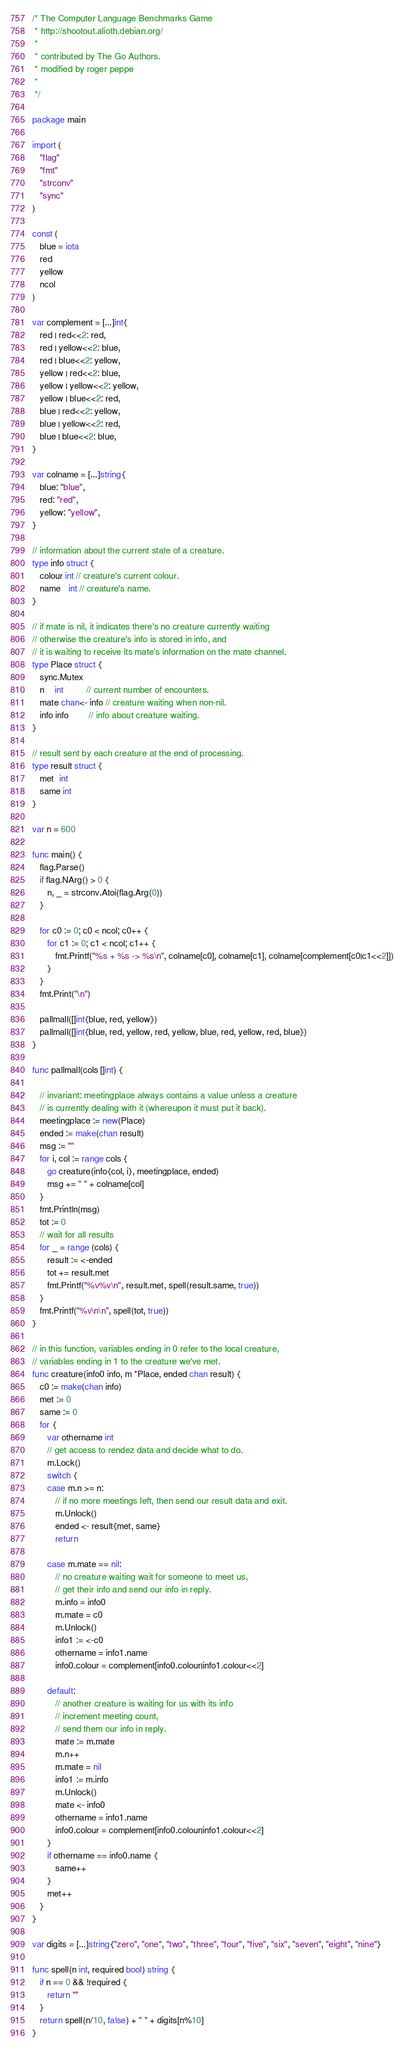<code> <loc_0><loc_0><loc_500><loc_500><_Go_>/* The Computer Language Benchmarks Game
 * http://shootout.alioth.debian.org/
 *
 * contributed by The Go Authors.
 * modified by roger peppe
 * 
 */

package main

import (
   "flag"
   "fmt"
   "strconv"
   "sync"
)

const (
   blue = iota
   red
   yellow
   ncol
)

var complement = [...]int{
   red | red<<2: red,
   red | yellow<<2: blue,
   red | blue<<2: yellow,
   yellow | red<<2: blue,
   yellow | yellow<<2: yellow,
   yellow | blue<<2: red,
   blue | red<<2: yellow,
   blue | yellow<<2: red,
   blue | blue<<2: blue,
}

var colname = [...]string{
   blue: "blue",
   red: "red",
   yellow: "yellow",
}

// information about the current state of a creature.
type info struct {
   colour int // creature's current colour.
   name   int // creature's name.
}

// if mate is nil, it indicates there's no creature currently waiting
// otherwise the creature's info is stored in info, and
// it is waiting to receive its mate's information on the mate channel.
type Place struct {
   sync.Mutex
   n    int         // current number of encounters.
   mate chan<- info // creature waiting when non-nil.
   info info        // info about creature waiting.
}

// result sent by each creature at the end of processing.
type result struct {
   met  int
   same int
}

var n = 600

func main() {
   flag.Parse()
   if flag.NArg() > 0 {
      n, _ = strconv.Atoi(flag.Arg(0))
   }

   for c0 := 0; c0 < ncol; c0++ {
      for c1 := 0; c1 < ncol; c1++ {
         fmt.Printf("%s + %s -> %s\n", colname[c0], colname[c1], colname[complement[c0|c1<<2]])
      }
   }
   fmt.Print("\n")

   pallmall([]int{blue, red, yellow})
   pallmall([]int{blue, red, yellow, red, yellow, blue, red, yellow, red, blue})
}

func pallmall(cols []int) {

   // invariant: meetingplace always contains a value unless a creature
   // is currently dealing with it (whereupon it must put it back).
   meetingplace := new(Place)
   ended := make(chan result)
   msg := ""
   for i, col := range cols {
      go creature(info{col, i}, meetingplace, ended)
      msg += " " + colname[col]
   }
   fmt.Println(msg)
   tot := 0
   // wait for all results
   for _ = range (cols) {
      result := <-ended
      tot += result.met
      fmt.Printf("%v%v\n", result.met, spell(result.same, true))
   }
   fmt.Printf("%v\n\n", spell(tot, true))
}

// in this function, variables ending in 0 refer to the local creature,
// variables ending in 1 to the creature we've met.
func creature(info0 info, m *Place, ended chan result) {
   c0 := make(chan info)
   met := 0
   same := 0
   for {
      var othername int
      // get access to rendez data and decide what to do.
      m.Lock()
      switch {
      case m.n >= n:
         // if no more meetings left, then send our result data and exit.
         m.Unlock()
         ended <- result{met, same}
         return

      case m.mate == nil:
         // no creature waiting wait for someone to meet us,
         // get their info and send our info in reply.
         m.info = info0
         m.mate = c0
         m.Unlock()
         info1 := <-c0
         othername = info1.name
         info0.colour = complement[info0.colour|info1.colour<<2]

      default:
         // another creature is waiting for us with its info
         // increment meeting count,
         // send them our info in reply.
         mate := m.mate
         m.n++
         m.mate = nil
         info1 := m.info
         m.Unlock()
         mate <- info0
         othername = info1.name
         info0.colour = complement[info0.colour|info1.colour<<2]
      }
      if othername == info0.name {
         same++
      }
      met++
   }
}

var digits = [...]string{"zero", "one", "two", "three", "four", "five", "six", "seven", "eight", "nine"}

func spell(n int, required bool) string {
   if n == 0 && !required {
      return ""
   }
   return spell(n/10, false) + " " + digits[n%10]
}
</code> 